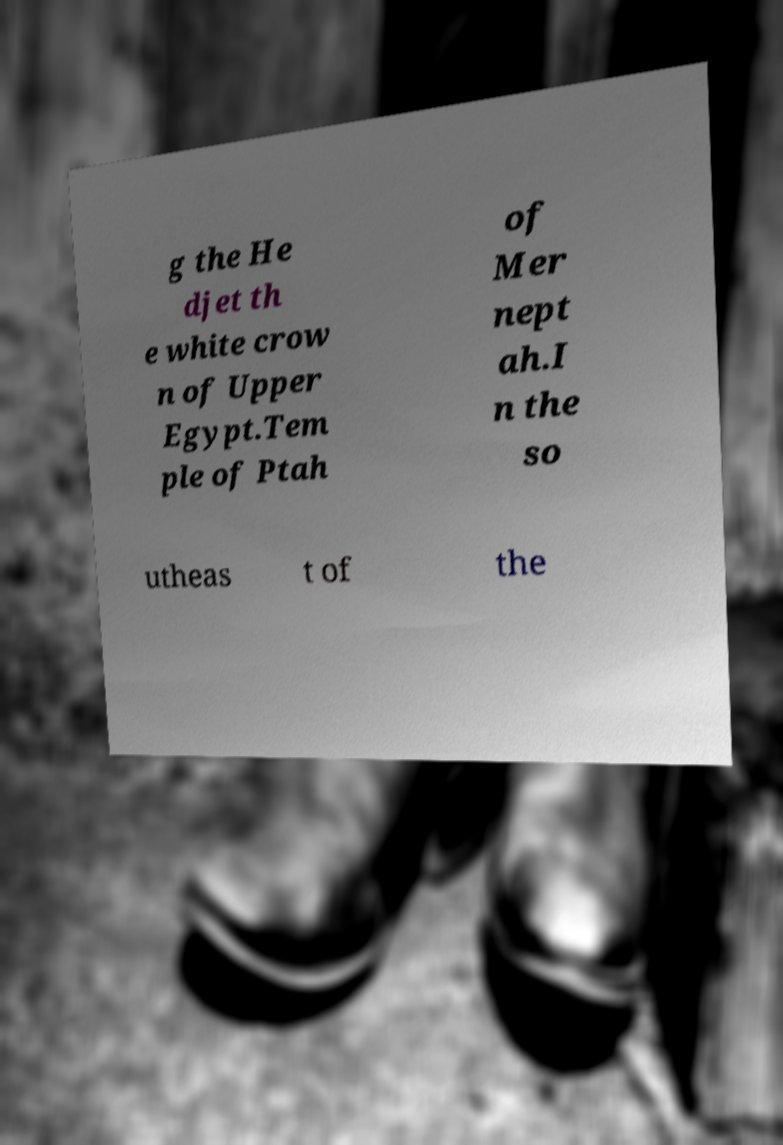Please identify and transcribe the text found in this image. g the He djet th e white crow n of Upper Egypt.Tem ple of Ptah of Mer nept ah.I n the so utheas t of the 